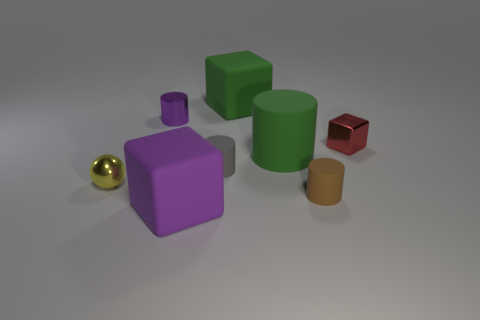Are there any other things that are the same shape as the yellow metal object?
Your response must be concise. No. What number of other matte cubes are the same size as the purple rubber block?
Your answer should be compact. 1. Are there fewer metal cylinders that are in front of the metallic ball than tiny cylinders?
Your answer should be compact. Yes. There is a shiny object to the right of the big rubber block that is to the right of the gray cylinder; what is its size?
Offer a very short reply. Small. What number of things are small rubber cylinders or large cylinders?
Give a very brief answer. 3. Is there a rubber object that has the same color as the tiny metal cylinder?
Ensure brevity in your answer.  Yes. Are there fewer metallic objects than brown rubber objects?
Your answer should be compact. No. What number of things are either tiny cyan metal things or matte things in front of the tiny purple metallic object?
Your answer should be very brief. 4. Are there any tiny purple cylinders that have the same material as the tiny red cube?
Your answer should be very brief. Yes. There is a cube that is the same size as the gray cylinder; what material is it?
Provide a succinct answer. Metal. 